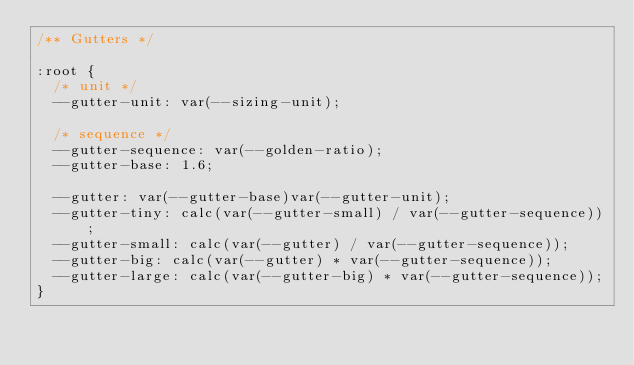Convert code to text. <code><loc_0><loc_0><loc_500><loc_500><_CSS_>/** Gutters */

:root {
  /* unit */
  --gutter-unit: var(--sizing-unit);

  /* sequence */
  --gutter-sequence: var(--golden-ratio);
  --gutter-base: 1.6;

  --gutter: var(--gutter-base)var(--gutter-unit);
  --gutter-tiny: calc(var(--gutter-small) / var(--gutter-sequence));
  --gutter-small: calc(var(--gutter) / var(--gutter-sequence));
  --gutter-big: calc(var(--gutter) * var(--gutter-sequence));
  --gutter-large: calc(var(--gutter-big) * var(--gutter-sequence));
}</code> 